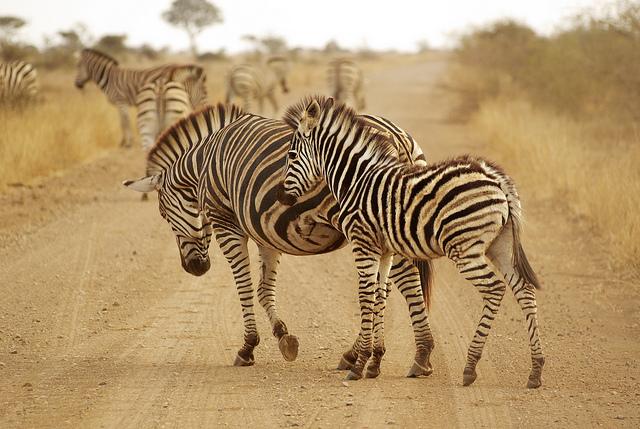Are the zebras facing the same direction?
Answer briefly. Yes. What color is the mane?
Short answer required. Black and white. How many animals can be seen?
Give a very brief answer. 7. Where are the zebras?
Give a very brief answer. Road. Do these zebras have similar patterns?
Be succinct. Yes. Is this area desert-like or lush and green?
Concise answer only. Desert-like. What is this animal doing?
Answer briefly. Walking. Are there any human-made objects in this scene?
Short answer required. No. Are the zebra roaming free?
Be succinct. Yes. Is this a game park?
Write a very short answer. No. Where are the animals walking?
Short answer required. Dirt road. 